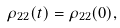<formula> <loc_0><loc_0><loc_500><loc_500>\rho _ { 2 2 } ( t ) = \rho _ { 2 2 } ( 0 ) ,</formula> 